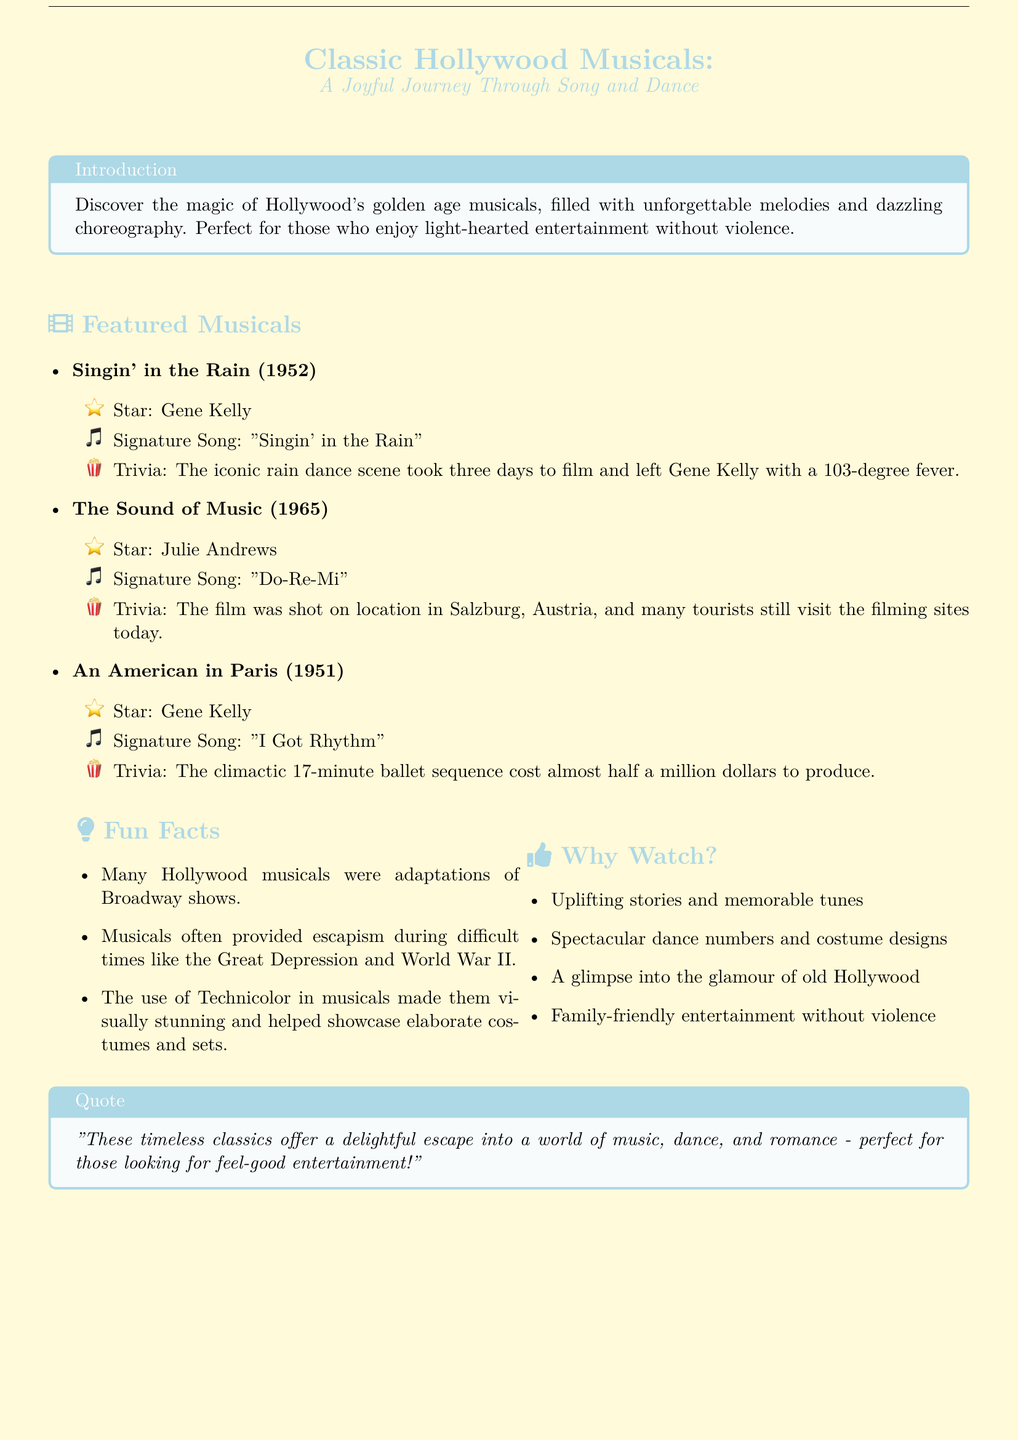What is the title of the featured musical from 1952? The title of the featured musical from 1952 is listed under "Featured Musicals".
Answer: Singin' in the Rain Who starred in "The Sound of Music"? The star for "The Sound of Music" is found in the trivia section of the document.
Answer: Julie Andrews What is the signature song of "An American in Paris"? The signature song is mentioned under the musical's details, specifically the song's category.
Answer: I Got Rhythm How long is the climactic ballet sequence in "An American in Paris"? The duration of the ballet sequence is stated in the trivia of the respective film.
Answer: 17 minutes What color is the background of the document? The overall color theme of the document is described in the introduction and the color usage sections.
Answer: goldenyellow What type of entertainment do these musicals provide? The document specifies the nature of the entertainment offered by the featured musicals.
Answer: family-friendly What was used in Hollywood musicals to create visually stunning effects? This information is discussed in the Fun Facts section of the document.
Answer: Technicolor Name one reason why musicals were popular during difficult times. The document includes reasoning for the popularity of musicals in a designated section.
Answer: escapism 